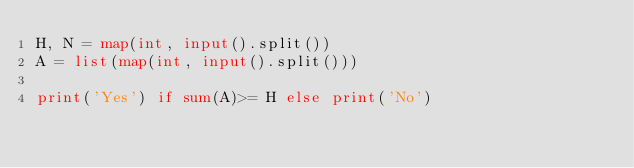<code> <loc_0><loc_0><loc_500><loc_500><_Python_>H, N = map(int, input().split())
A = list(map(int, input().split()))

print('Yes') if sum(A)>= H else print('No')

</code> 